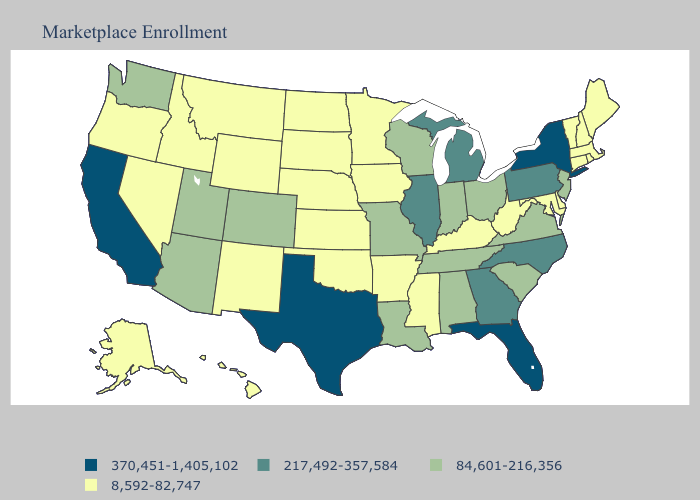What is the value of Alabama?
Concise answer only. 84,601-216,356. Which states hav the highest value in the South?
Write a very short answer. Florida, Texas. Among the states that border Colorado , does Kansas have the highest value?
Answer briefly. No. Which states have the lowest value in the MidWest?
Answer briefly. Iowa, Kansas, Minnesota, Nebraska, North Dakota, South Dakota. Does the first symbol in the legend represent the smallest category?
Give a very brief answer. No. Does the first symbol in the legend represent the smallest category?
Write a very short answer. No. What is the value of Iowa?
Give a very brief answer. 8,592-82,747. Name the states that have a value in the range 370,451-1,405,102?
Be succinct. California, Florida, New York, Texas. What is the lowest value in states that border New Hampshire?
Keep it brief. 8,592-82,747. What is the value of New York?
Concise answer only. 370,451-1,405,102. What is the value of Florida?
Answer briefly. 370,451-1,405,102. Does the map have missing data?
Concise answer only. No. Among the states that border Wisconsin , which have the highest value?
Write a very short answer. Illinois, Michigan. What is the value of Pennsylvania?
Keep it brief. 217,492-357,584. What is the highest value in states that border Iowa?
Give a very brief answer. 217,492-357,584. 